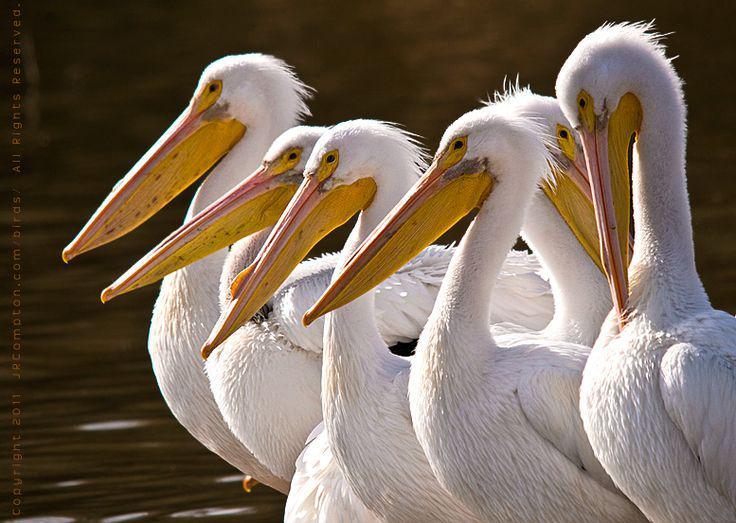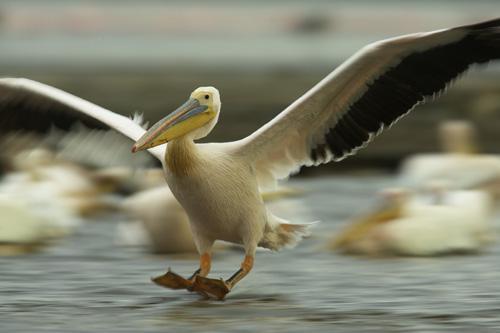The first image is the image on the left, the second image is the image on the right. Considering the images on both sides, is "All the birds in the image on the left are floating on the water." valid? Answer yes or no. No. 